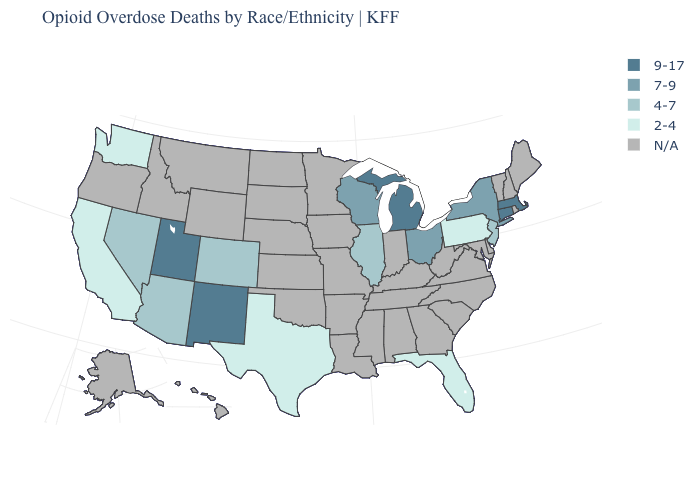What is the value of Hawaii?
Be succinct. N/A. Name the states that have a value in the range 4-7?
Short answer required. Arizona, Colorado, Illinois, Nevada, New Jersey. What is the value of Rhode Island?
Write a very short answer. N/A. Does the first symbol in the legend represent the smallest category?
Short answer required. No. What is the lowest value in the USA?
Be succinct. 2-4. What is the lowest value in the Northeast?
Concise answer only. 2-4. Name the states that have a value in the range 7-9?
Give a very brief answer. New York, Ohio, Wisconsin. What is the value of Louisiana?
Answer briefly. N/A. What is the highest value in the USA?
Quick response, please. 9-17. Among the states that border Idaho , which have the highest value?
Be succinct. Utah. What is the lowest value in the South?
Be succinct. 2-4. What is the highest value in the MidWest ?
Concise answer only. 9-17. Does Washington have the lowest value in the USA?
Quick response, please. Yes. 